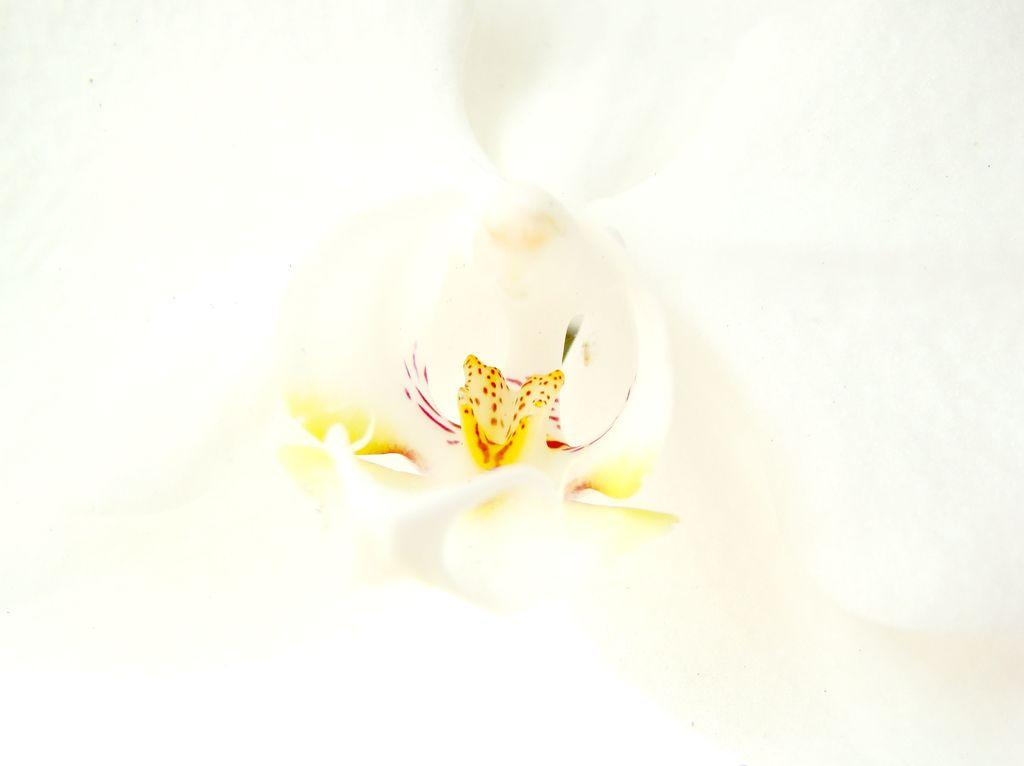What is the main subject of the picture? The main subject of the picture is a flower. Can you describe the colors of the flower? The flower has white, yellow, and red colors. What color is the background of the image? The background of the image is white. What type of soda is being served at the event in the image? There is no event or soda present in the image; it features a flower with white, yellow, and red colors against a white background. 